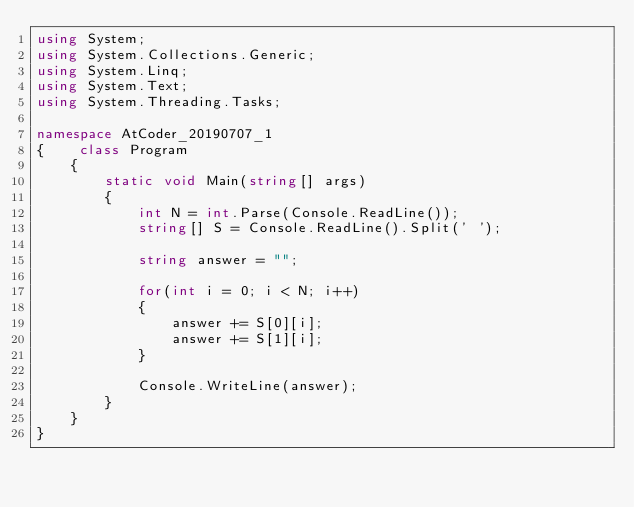Convert code to text. <code><loc_0><loc_0><loc_500><loc_500><_C#_>using System;
using System.Collections.Generic;
using System.Linq;
using System.Text;
using System.Threading.Tasks;

namespace AtCoder_20190707_1
{    class Program
    {
        static void Main(string[] args)
        {
            int N = int.Parse(Console.ReadLine());
            string[] S = Console.ReadLine().Split(' ');

            string answer = "";

            for(int i = 0; i < N; i++)
            {
                answer += S[0][i];
                answer += S[1][i];
            }

            Console.WriteLine(answer);
        }
    }
}</code> 